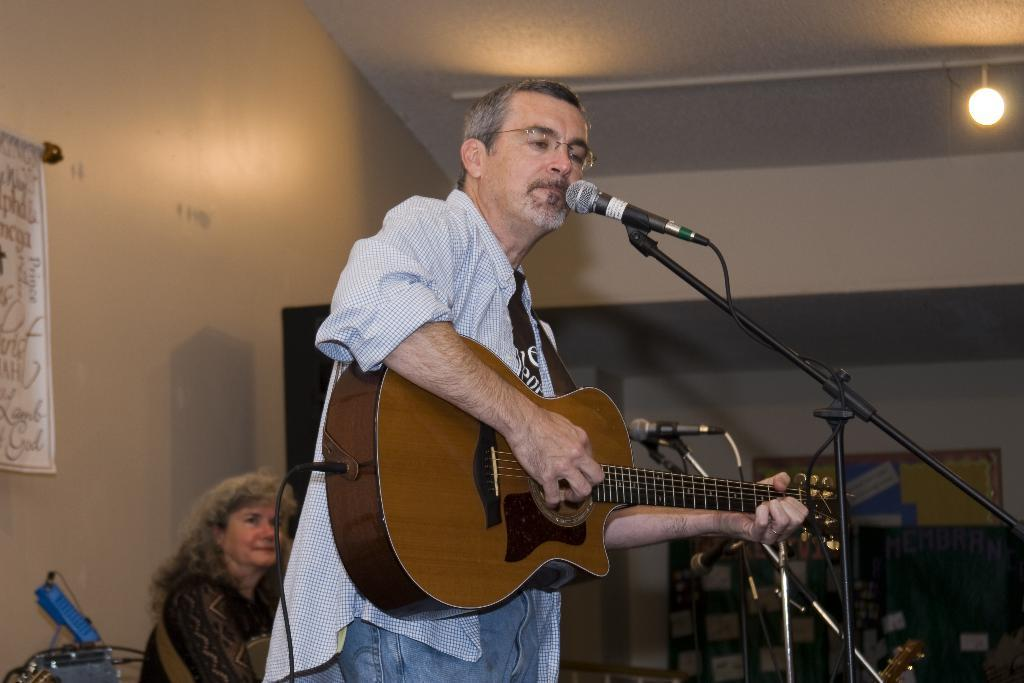What is the person in the image doing? The person is playing a guitar and singing. What object is the person using to amplify their voice? There is a microphone with a holder in the image. Can you describe the lighting in the image? There is a light on top in the image. What is the position of the woman in the image? The woman is sitting in the image. What is on the wall in the image? There is a poster on the wall in the image. How does the stranger in the image interact with the creator of the poster? There is no stranger or creator of the poster present in the image. 